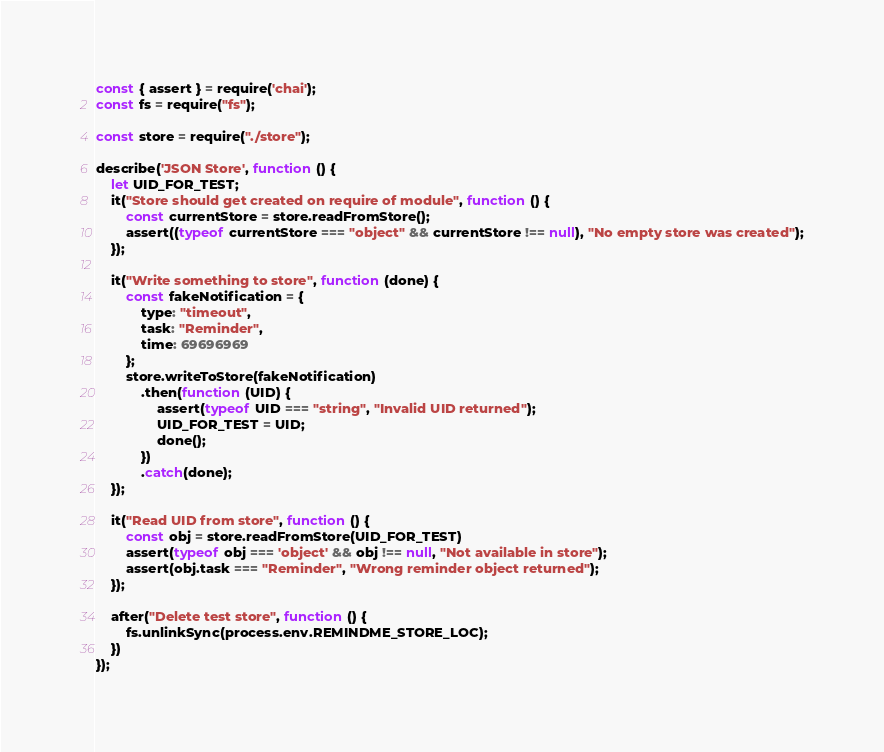Convert code to text. <code><loc_0><loc_0><loc_500><loc_500><_JavaScript_>const { assert } = require('chai');
const fs = require("fs");

const store = require("./store");

describe('JSON Store', function () {
	let UID_FOR_TEST;
	it("Store should get created on require of module", function () {
		const currentStore = store.readFromStore();
		assert((typeof currentStore === "object" && currentStore !== null), "No empty store was created");
	});

	it("Write something to store", function (done) {
		const fakeNotification = {
			type: "timeout",
			task: "Reminder",
			time: 69696969
		};
		store.writeToStore(fakeNotification)
			.then(function (UID) {
				assert(typeof UID === "string", "Invalid UID returned");
				UID_FOR_TEST = UID;
				done();
			})
			.catch(done);
	});

	it("Read UID from store", function () {
		const obj = store.readFromStore(UID_FOR_TEST)
		assert(typeof obj === 'object' && obj !== null, "Not available in store");
		assert(obj.task === "Reminder", "Wrong reminder object returned");
	});

	after("Delete test store", function () {
		fs.unlinkSync(process.env.REMINDME_STORE_LOC);
	})
});</code> 